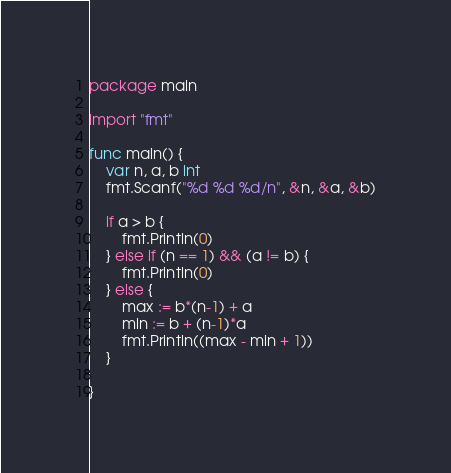<code> <loc_0><loc_0><loc_500><loc_500><_Go_>package main

import "fmt"

func main() {
	var n, a, b int
	fmt.Scanf("%d %d %d/n", &n, &a, &b)

	if a > b {
		fmt.Println(0)
	} else if (n == 1) && (a != b) {
		fmt.Println(0)
	} else {
		max := b*(n-1) + a
		min := b + (n-1)*a
		fmt.Println((max - min + 1))
	}

}
</code> 